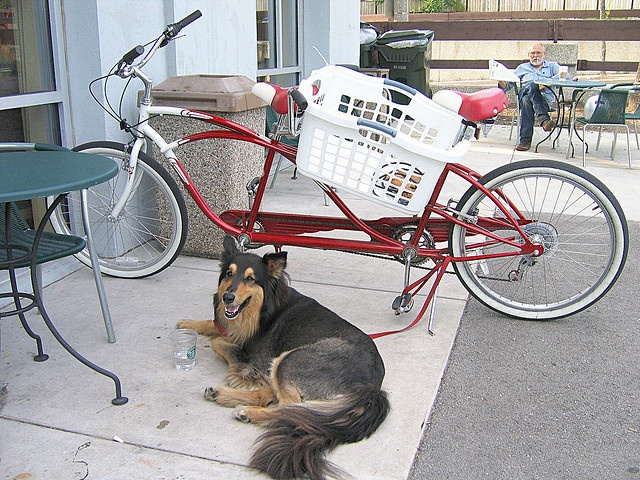Describe the objects in this image and their specific colors. I can see bicycle in black, lightgray, darkgray, and gray tones, dog in black, gray, and tan tones, dining table in black, teal, gray, and darkgray tones, chair in black, gray, purple, and darkgray tones, and people in black, white, gray, lightblue, and blue tones in this image. 